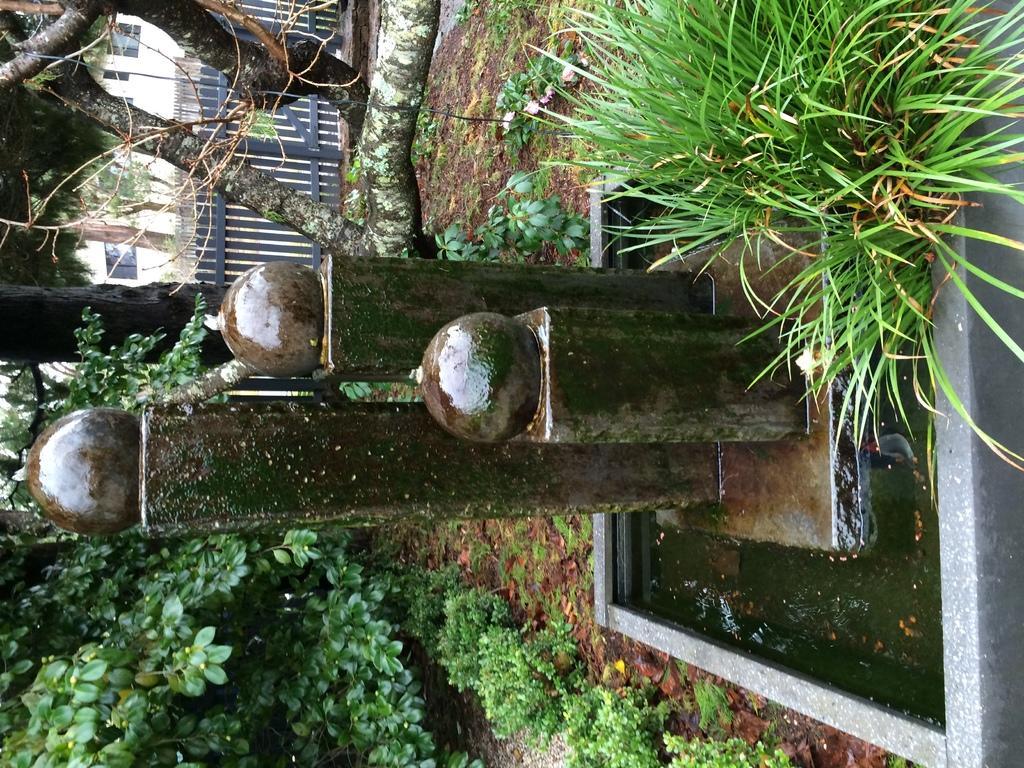In one or two sentences, can you explain what this image depicts? In this picture I can see a water feature, there is grass, fence, there are plants, trees, this is looking like a building. 